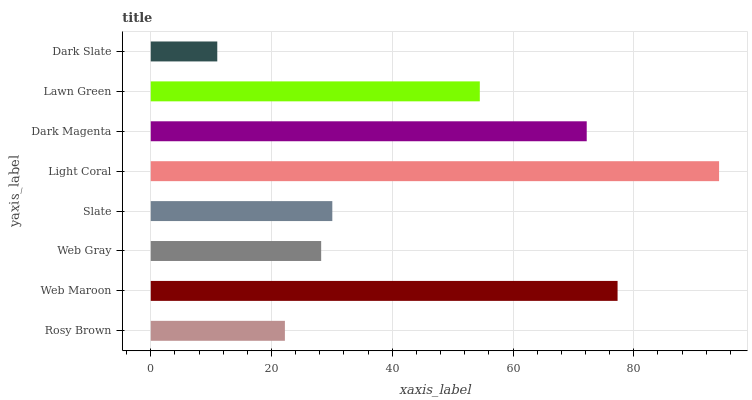Is Dark Slate the minimum?
Answer yes or no. Yes. Is Light Coral the maximum?
Answer yes or no. Yes. Is Web Maroon the minimum?
Answer yes or no. No. Is Web Maroon the maximum?
Answer yes or no. No. Is Web Maroon greater than Rosy Brown?
Answer yes or no. Yes. Is Rosy Brown less than Web Maroon?
Answer yes or no. Yes. Is Rosy Brown greater than Web Maroon?
Answer yes or no. No. Is Web Maroon less than Rosy Brown?
Answer yes or no. No. Is Lawn Green the high median?
Answer yes or no. Yes. Is Slate the low median?
Answer yes or no. Yes. Is Light Coral the high median?
Answer yes or no. No. Is Web Maroon the low median?
Answer yes or no. No. 